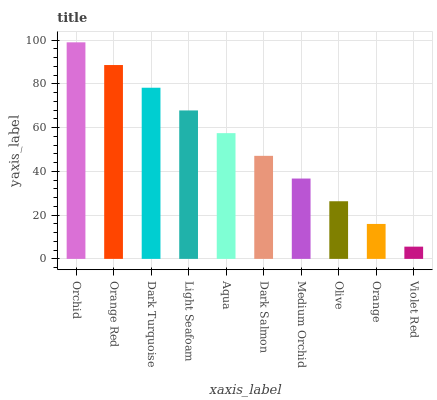Is Violet Red the minimum?
Answer yes or no. Yes. Is Orchid the maximum?
Answer yes or no. Yes. Is Orange Red the minimum?
Answer yes or no. No. Is Orange Red the maximum?
Answer yes or no. No. Is Orchid greater than Orange Red?
Answer yes or no. Yes. Is Orange Red less than Orchid?
Answer yes or no. Yes. Is Orange Red greater than Orchid?
Answer yes or no. No. Is Orchid less than Orange Red?
Answer yes or no. No. Is Aqua the high median?
Answer yes or no. Yes. Is Dark Salmon the low median?
Answer yes or no. Yes. Is Orange Red the high median?
Answer yes or no. No. Is Orchid the low median?
Answer yes or no. No. 